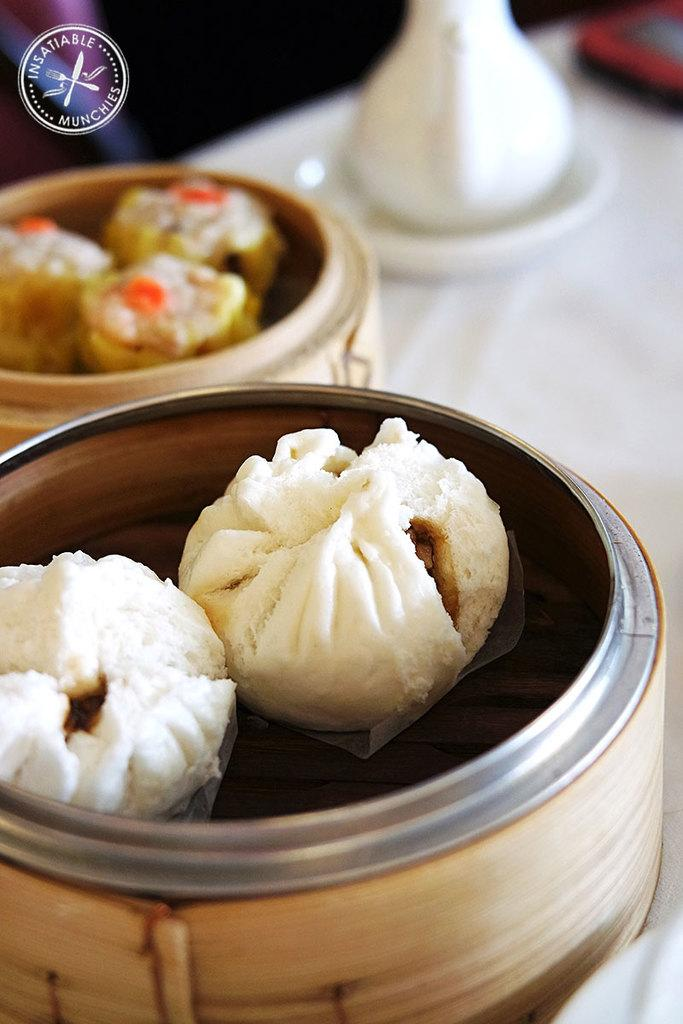<image>
Give a short and clear explanation of the subsequent image. Dim Sum containers are on a table with the logo for Insatiable Munchies on the image. 